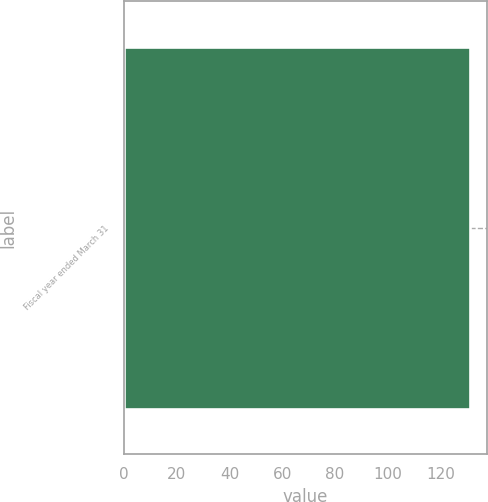<chart> <loc_0><loc_0><loc_500><loc_500><bar_chart><fcel>Fiscal year ended March 31<nl><fcel>131<nl></chart> 